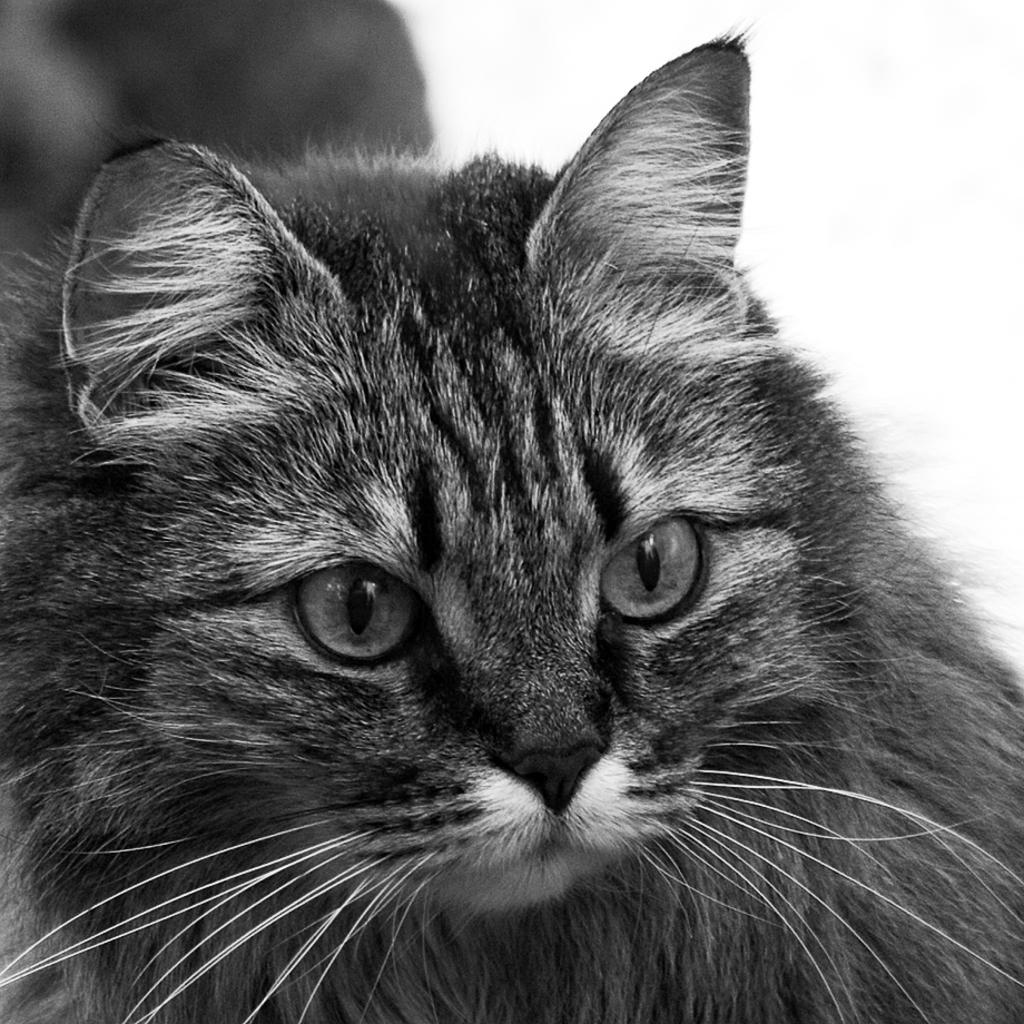What type of animal is featured in the black and white picture in the image? The image contains a black and white picture of a cat. Can you describe the background of the image? The background of the image is blurred. What invention is being demonstrated by the cat in the image? There is no invention being demonstrated by the cat in the image, as it is a static black and white picture of a cat. What type of bird can be seen perched on the edge of the image? There is no bird present in the image, and therefore no bird can be seen perched on the edge. 